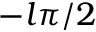Convert formula to latex. <formula><loc_0><loc_0><loc_500><loc_500>- l \pi / 2</formula> 